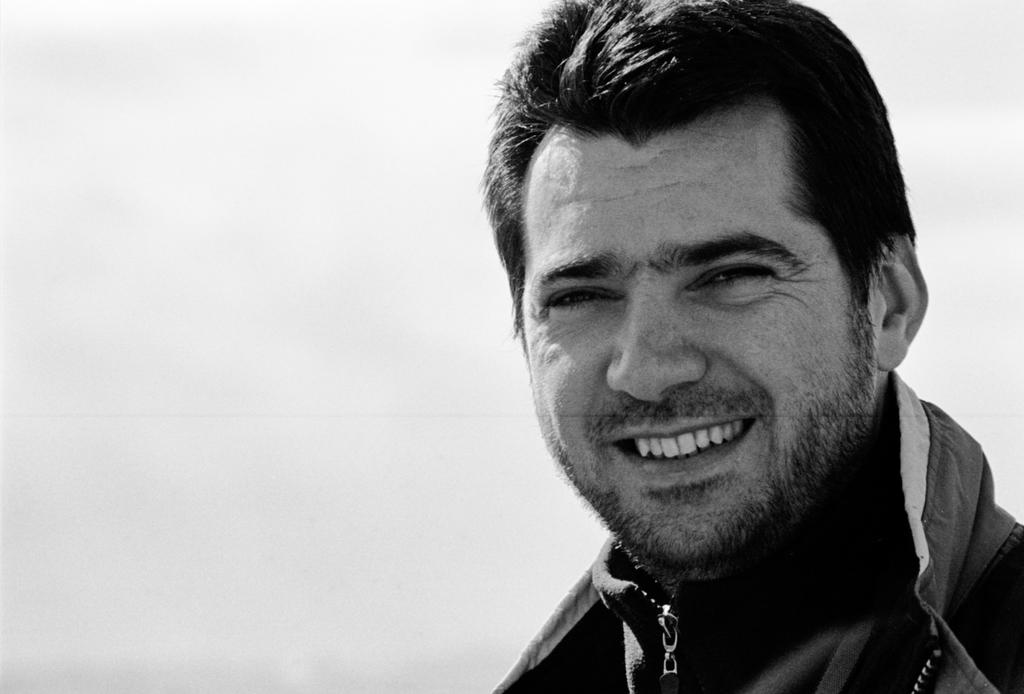What is present in the image? There is a person in the image. How is the person's expression in the image? The person is smiling. What color scheme is used in the image? The image is in black and white color. How many fish can be seen swimming in the tank in the image? There is no fish or tank present in the image; it features a person in black and white color. What type of rhythm is the person dancing to in the image? There is no indication of dancing or rhythm in the image; the person is simply smiling. 